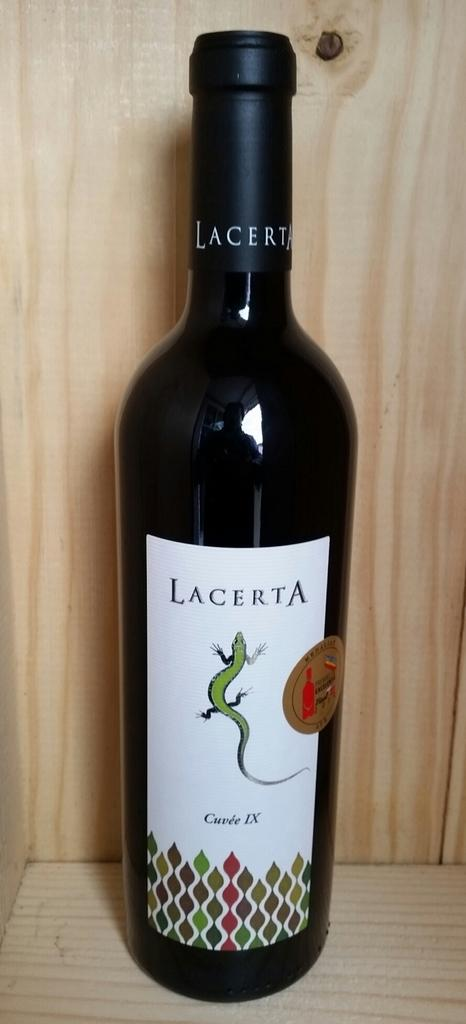<image>
Offer a succinct explanation of the picture presented. The Lacerta wine bottle has a green lizard on it. 